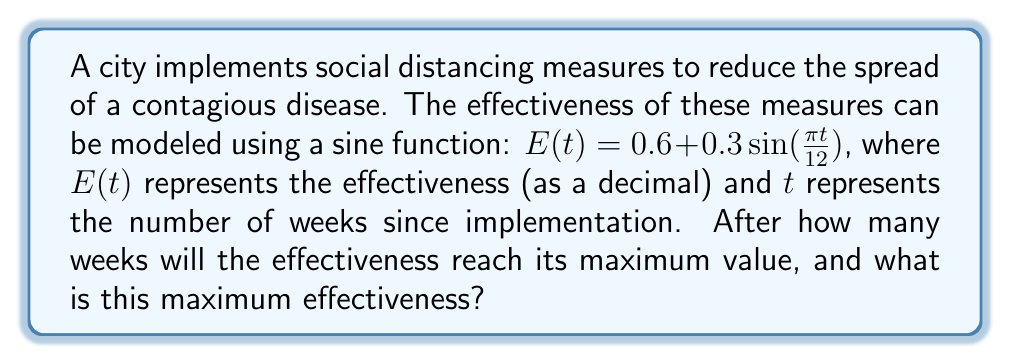Can you solve this math problem? To solve this problem, we need to analyze the given sine function and determine its period and amplitude.

1) The general form of a sine function is:
   $f(t) = A\sin(Bt) + C$
   where $A$ is the amplitude, $B$ is the angular frequency, and $C$ is the vertical shift.

2) In our function $E(t) = 0.6 + 0.3\sin(\frac{\pi t}{12})$:
   $A = 0.3$ (amplitude)
   $B = \frac{\pi}{12}$ (angular frequency)
   $C = 0.6$ (vertical shift)

3) The period of a sine function is given by $\frac{2\pi}{B}$:
   Period $= \frac{2\pi}{\frac{\pi}{12}} = 24$ weeks

4) The maximum value occurs at $\frac{1}{4}$ of the period:
   Time to maximum $= \frac{24}{4} = 6$ weeks

5) The maximum value is calculated by adding the vertical shift to the amplitude:
   Maximum effectiveness $= C + A = 0.6 + 0.3 = 0.9$ or 90%

[asy]
import graph;
size(200,150);
real f(real x) {return 0.6+0.3*sin(pi*x/12);}
draw(graph(f,0,24));
ylimits(0,1);
xaxis("Weeks",Ticks);
yaxis("Effectiveness",Ticks);
label("Maximum at 6 weeks",(6,0.9),N);
dot((6,0.9));
[/asy]
Answer: 6 weeks; 0.9 (90% effectiveness) 